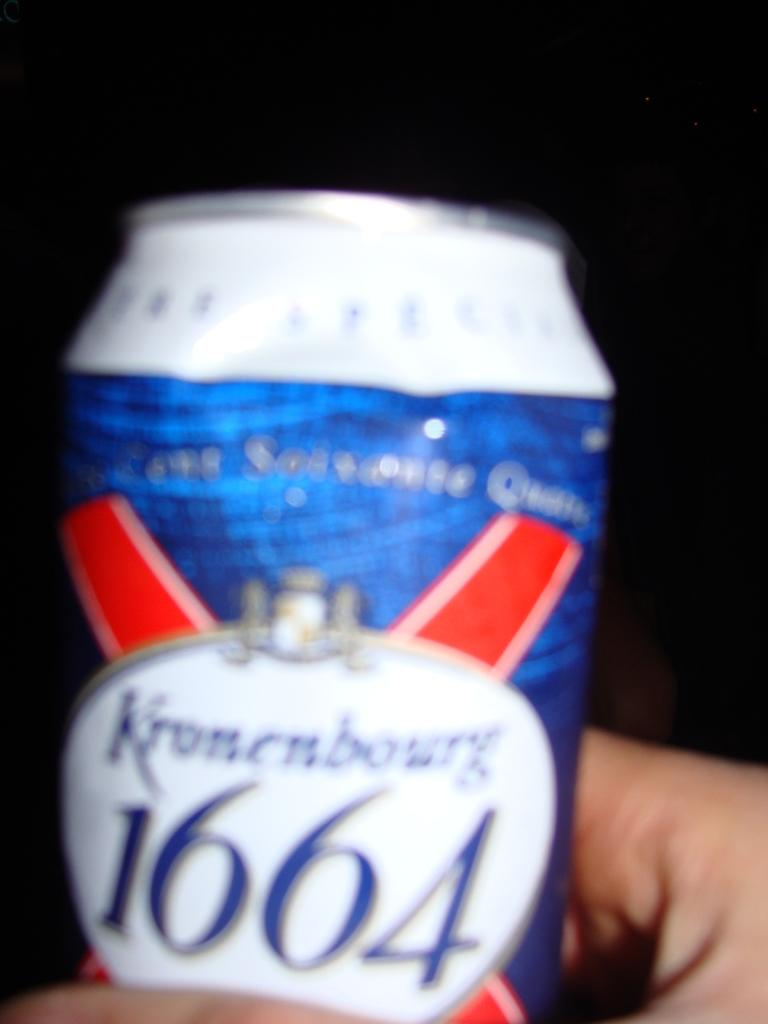<image>
Relay a brief, clear account of the picture shown. Blue, red, and white can with 1664 wrote on the front 